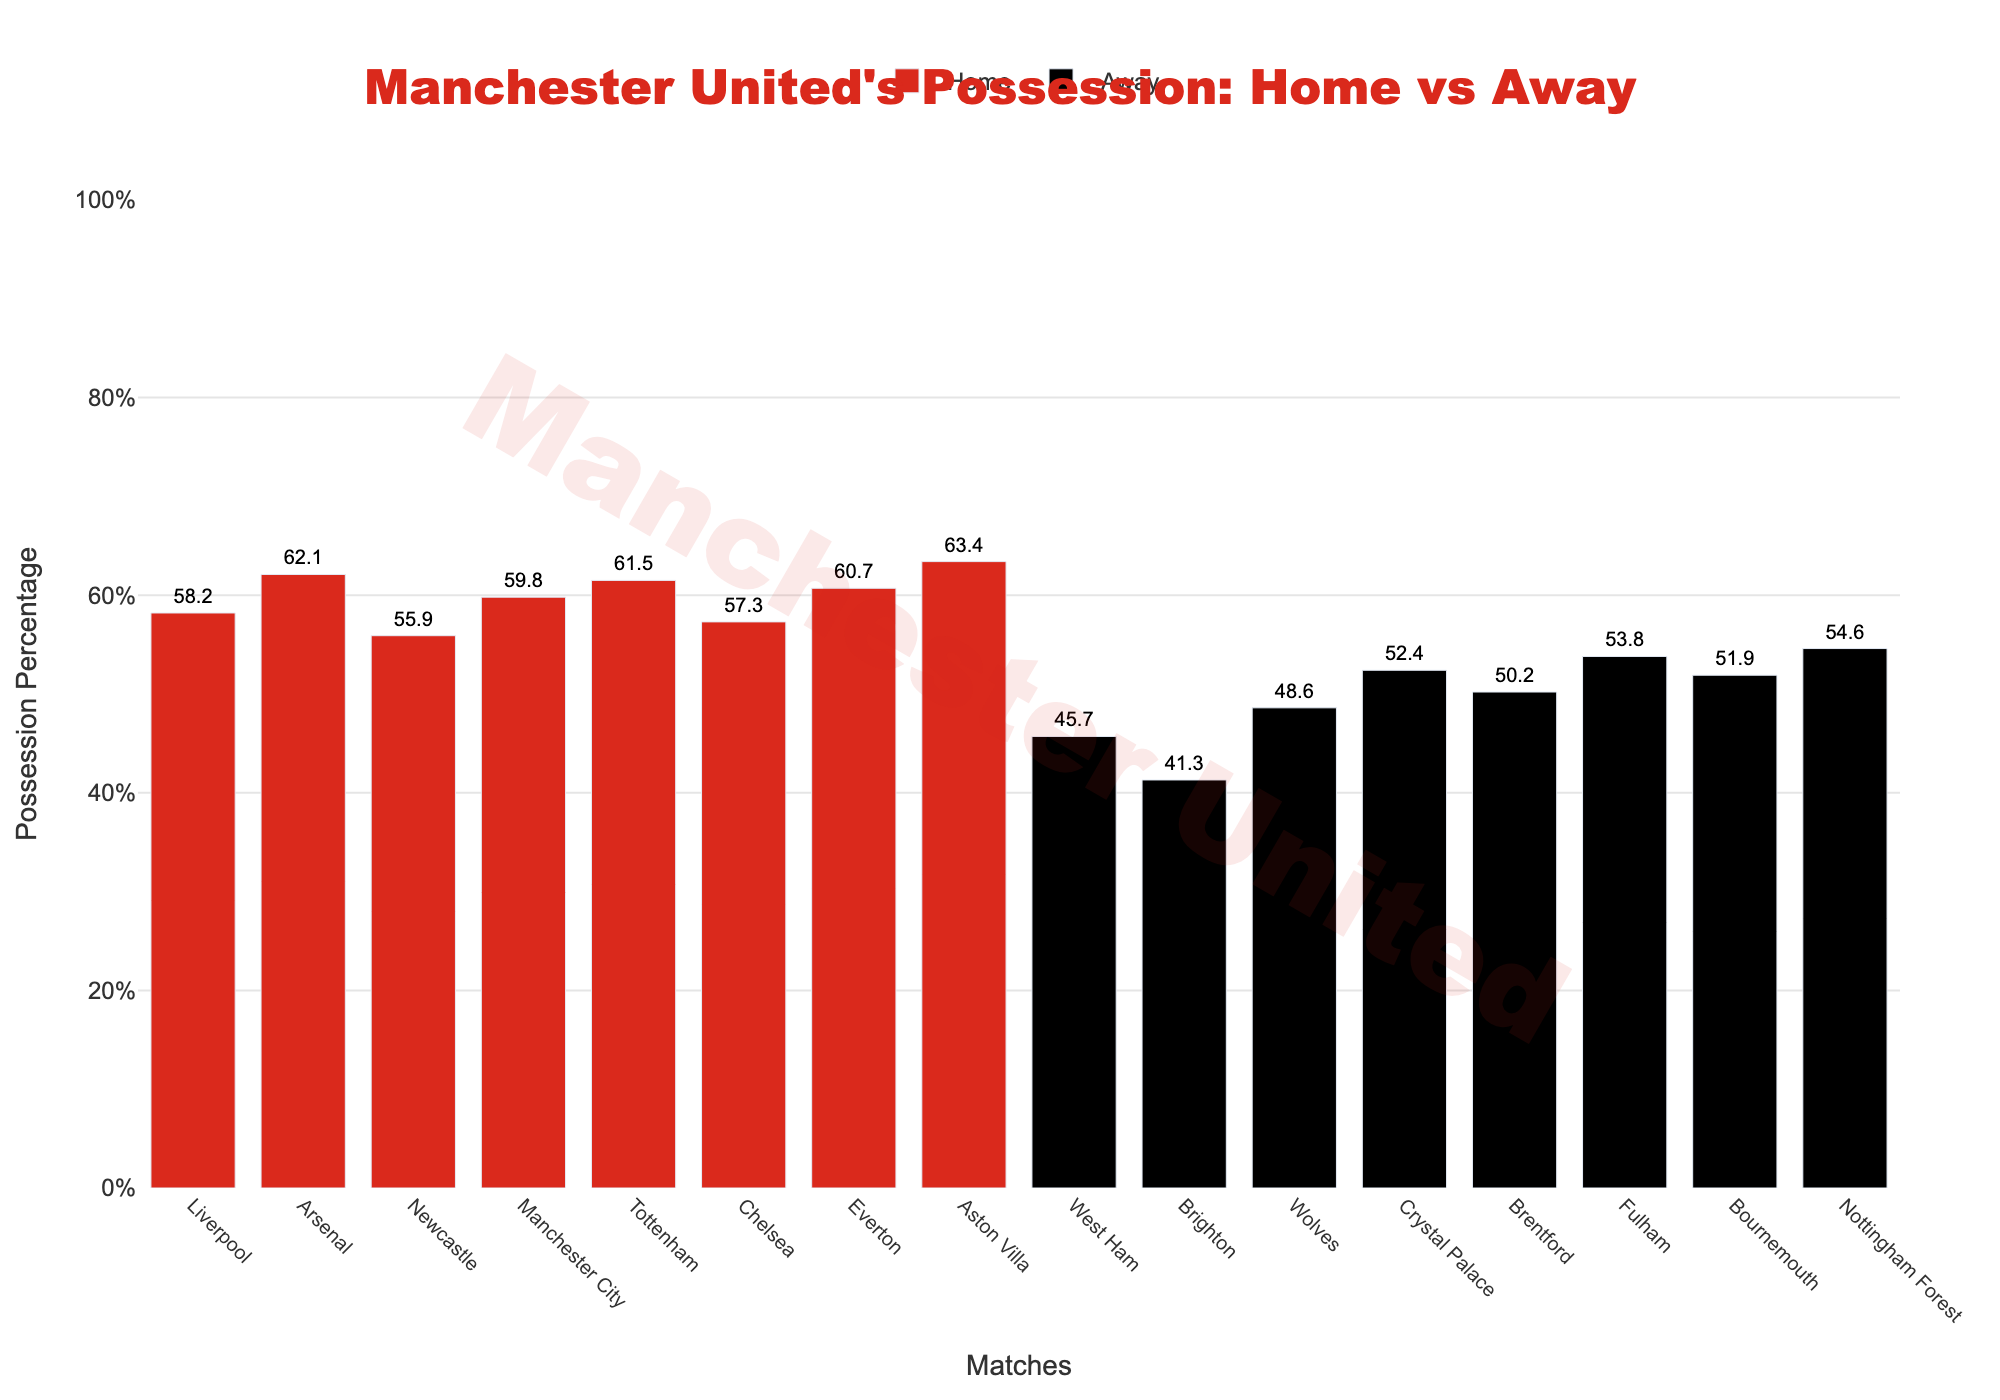Which match had the highest possession percentage for home matches? To identify the match with the highest possession percentage for home matches, we look at the heights of the red bars representing home matches. The tallest bar corresponds to the match against Bournemouth, with a possession percentage of 63.4%
Answer: Bournemouth Which match had the lowest possession percentage for away matches? To identify the match with the lowest possession percentage for away matches, we check the heights of the black bars representing away matches. The shortest bar corresponds to the match against Manchester City, with a possession percentage of 41.3%
Answer: Manchester City What is the average possession percentage for home matches? To find the average possession percentage for home matches, sum all percentages for home matches and divide by the total number of home matches. The calculation is (58.2 + 62.1 + 55.9 + 59.8 + 61.5 + 57.3 + 60.7 + 63.4) / 8 = 59.86
Answer: 59.86 What is the possession percentage difference between the home match against West Ham and the away match against Crystal Palace? To find the difference, subtract the possession percentage of the away match against Crystal Palace from that of the home match against West Ham. The calculation is 61.5% - 53.8% = 7.7%
Answer: 7.7% Is the possession percentage generally higher in home matches or away matches? By comparing the general height of the red bars (home) to the black bars (away), we see that the red bars are generally taller, indicating a higher possession percentage in home matches
Answer: Home matches How many home matches had a possession percentage above 60%? To count the number of home matches with possession percentages above 60%, identify the red bars that surpass the 60% line. These matches are against Newcastle, Everton, Brentford, and Bournemouth, totaling 4 matches
Answer: 4 What is the total possession percentage for all away matches combined? To find the total possession percentage for all away matches, sum the percentages of the away matches. The calculation is 45.7 + 41.3 + 48.6 + 52.4 + 50.2 + 53.8 + 51.9 + 54.6 = 398.5
Answer: 398.5 Which match shows the smallest percentage difference in possession between the home and away values? To find the smallest difference in possession values between matches, we compare the difference between the home and away percentages for each opponent. The match against Aston Villa has the smallest difference: 59.8% (home) - 52.4% (away) = 7.4%
Answer: Aston Villa Considering the matches against top-six teams (Liverpool, Arsenal, Manchester City, Tottenham, and Chelsea), which had the highest possession percentage for Manchester United? We identify the possession percentage for matches against Liverpool, Arsenal, Manchester City, Tottenham, and Chelsea. The highest possession percentage among these is against Liverpool at 58.2%
Answer: Liverpool 